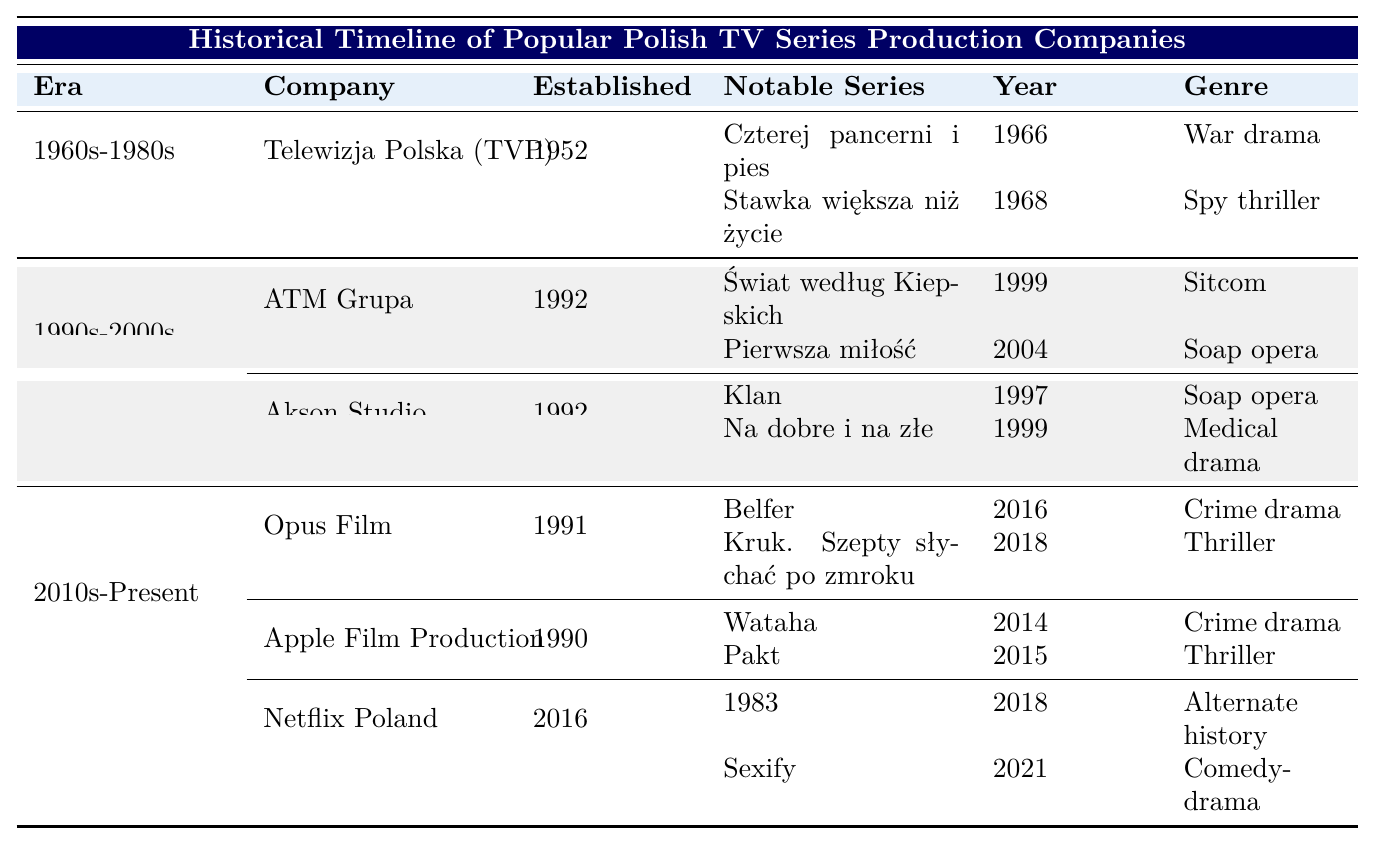What company produced the series "Czterej pancerni i pies"? The table shows that "Czterej pancerni i pies" was produced by Telewizja Polska (TVP) during the era of 1960s-1980s.
Answer: Telewizja Polska (TVP) In what year was "Wataha" first aired? According to the table, "Wataha" was first aired in 2014, produced by Apple Film Production.
Answer: 2014 How many notable series did ATM Grupa produce? The table indicates that ATM Grupa produced two notable series: "Świat według Kiepskich" and "Pierwsza miłość."
Answer: 2 What genre is "Sexify"? The table states that "Sexify," produced by Netflix Poland, is a comedy-drama.
Answer: Comedy-drama Which company was established first, Apple Film Production or Opus Film? The table shows that Apple Film Production was established in 1990, while Opus Film was established in 1991. Therefore, Apple Film Production is the older company.
Answer: Apple Film Production How many series were produced in the 1990s-2000s era? The table lists four notable series from the 1990s-2000s era: "Świat według Kiepskich," "Pierwsza miłość," "Klan," and "Na dobre i na złe."
Answer: 4 Is "Kruk. Szepty słychać po zmroku" a thriller? The table indicates that "Kruk. Szepty słychać po zmroku," produced by Opus Film, is categorized as a thriller.
Answer: Yes Which era did the series "1983" belong to? The table categorizes "1983" as part of the era from 2010s-Present, produced by Netflix Poland.
Answer: 2010s-Present What is the average year of establishment for the companies listed? Companies established are: 1952 (TVP), 1992 (ATM Grupa), 1992 (Akson Studio), 1991 (Opus Film), 1990 (Apple Film Production), and 2016 (Netflix Poland). Summing these gives 1952 + 1992 + 1992 + 1991 + 1990 + 2016 = 11933. Dividing by 6 gives an average year of approximately 1988.83.
Answer: 1989 Which genre had the most notable series listed across all companies in this timeline? The notable series by genre are: War drama (1), Spy thriller (1), Sitcom (1), Soap opera (3), Medical drama (1), Crime drama (3), Thriller (3), Alternate history (1), Comedy-drama (1). The highest count is for Soap opera, Crime drama, and Thriller, each with 3 series.
Answer: Soap opera, Crime drama, and Thriller 